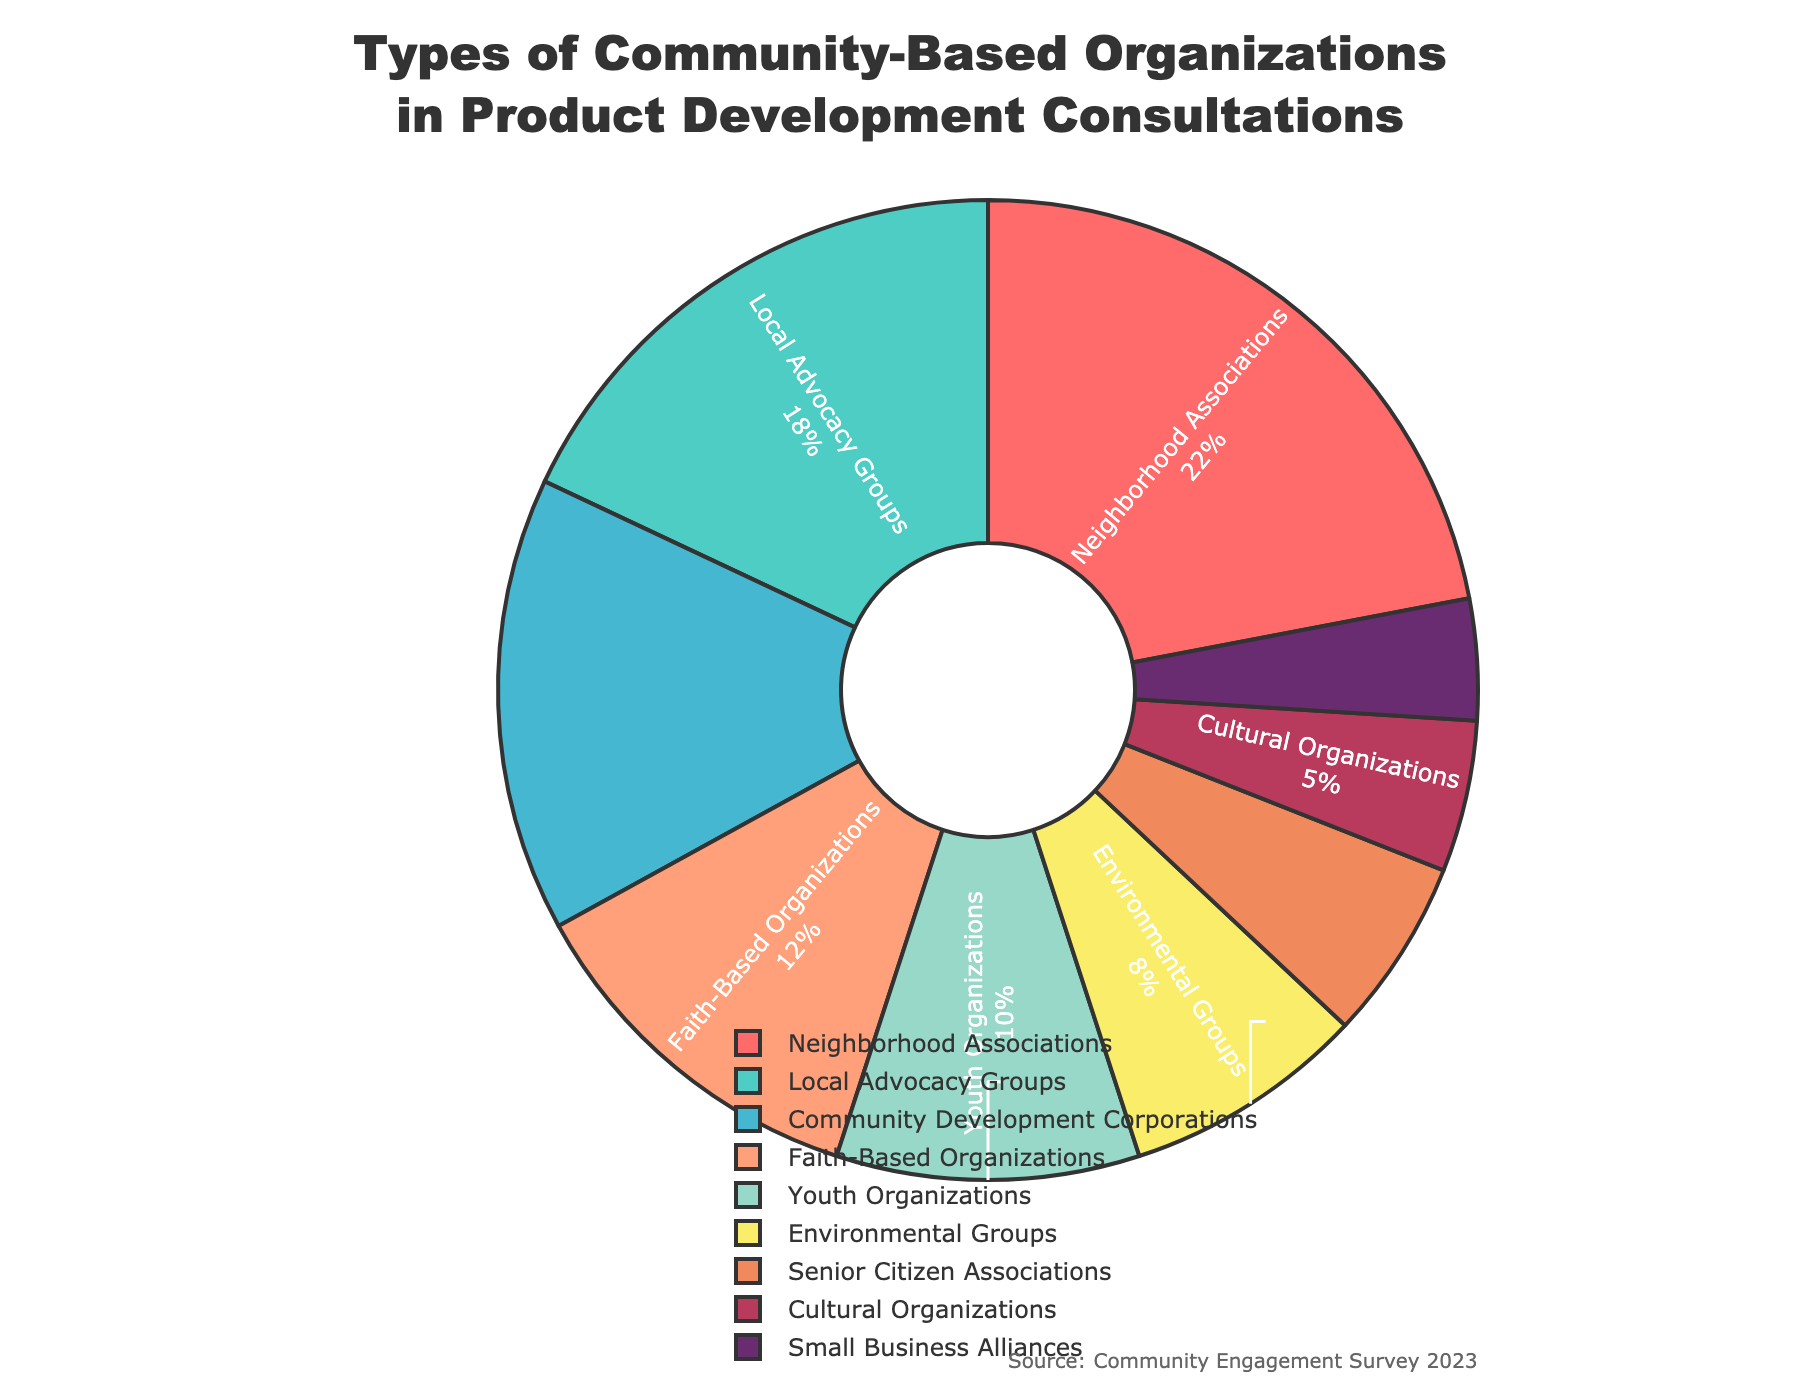Which type of community-based organization is involved the most in product development consultations? By examining the pie chart, we can observe that the "Neighborhood Associations" segment is the largest. It is labeled 22%, which is the highest percentage among the given categories.
Answer: Neighborhood Associations Comparing Local Advocacy Groups and Youth Organizations, which has a higher percentage of involvement and by how much? "Local Advocacy Groups" have an involvement percentage of 18% while "Youth Organizations" have 10%. The difference is calculated by subtracting the percentage of Youth Organizations from that of Local Advocacy Groups, which is 18% - 10% = 8%.
Answer: Local Advocacy Groups by 8% What is the combined percentage of involvement for Faith-Based Organizations and Environmental Groups? The involvement percentage of Faith-Based Organizations is 12% and Environmental Groups is 8%. Adding these together, we get 12% + 8% = 20%.
Answer: 20% Among Cultural Organizations and Small Business Alliances, which type of organization has a smaller percentage of involvement and what is that percentage? Looking at the pie chart, "Small Business Alliances" have an involvement percentage of 4% and "Cultural Organizations" have 5%. Therefore, "Small Business Alliances" have a smaller percentage.
Answer: Small Business Alliances, 4% How many types of community-based organizations have an involvement percentage of 10% or less? By scanning the pie chart, the organizations with 10% or less involvement are Youth Organizations (10%), Environmental Groups (8%), Senior Citizen Associations (6%), Cultural Organizations (5%), and Small Business Alliances (4%). Counting these, we get 5 organizations.
Answer: 5 What is the difference in involvement percentage between the highest and the lowest involved organizations? The highest involved organization is Neighborhood Associations with 22% and the lowest involved is Small Business Alliances with 4%. The difference is 22% - 4% = 18%.
Answer: 18% What are the visual colors representing Neighborhood Associations, and Environmental Groups on the pie chart? By observing the colors used in the pie chart, "Neighborhood Associations" is represented by the color red, and "Environmental Groups" is represented by yellow.
Answer: Red for Neighborhood Associations and yellow for Environmental Groups 